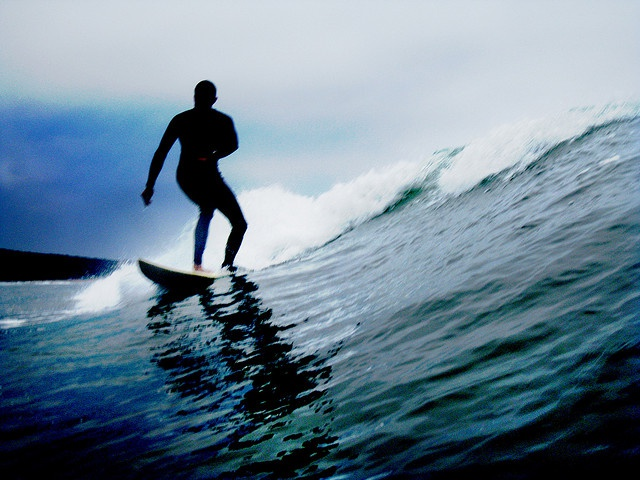Describe the objects in this image and their specific colors. I can see people in lightgray, black, navy, blue, and lightblue tones and surfboard in lightgray, black, and darkgray tones in this image. 